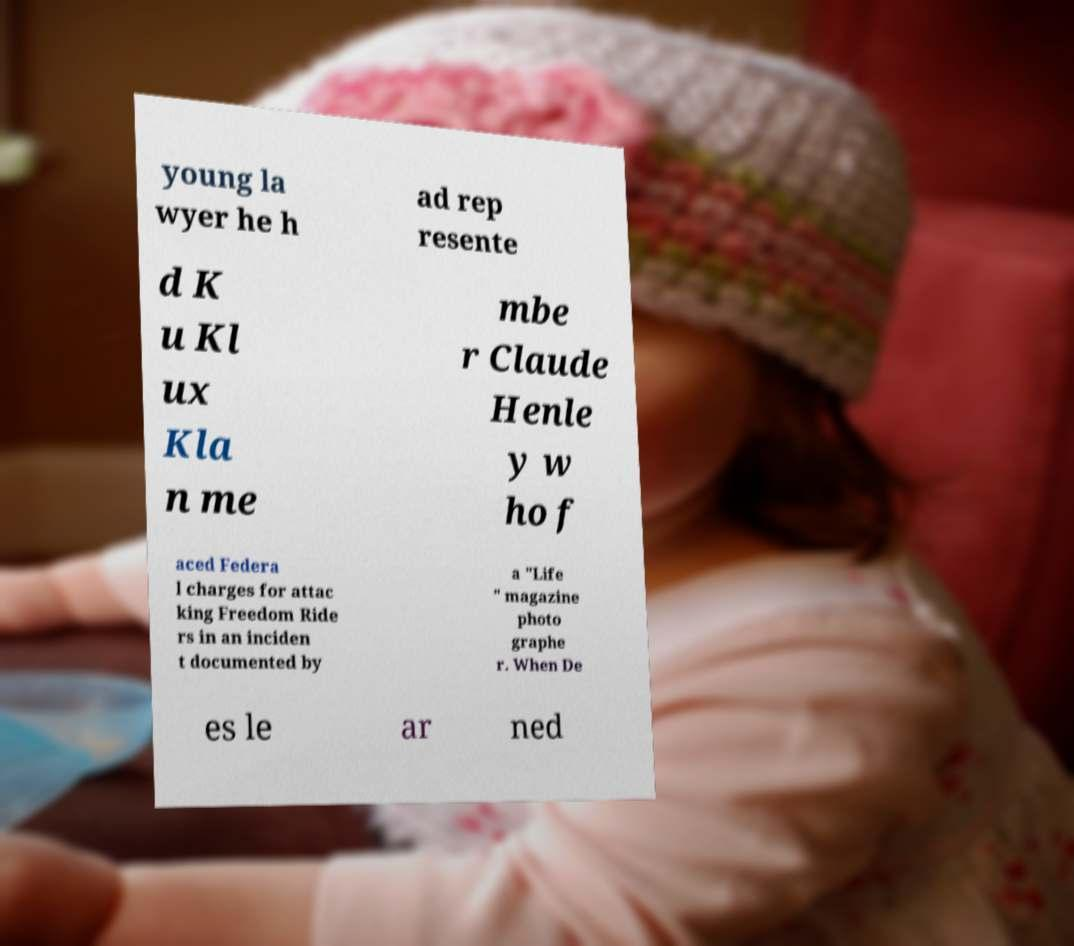Please read and relay the text visible in this image. What does it say? young la wyer he h ad rep resente d K u Kl ux Kla n me mbe r Claude Henle y w ho f aced Federa l charges for attac king Freedom Ride rs in an inciden t documented by a "Life " magazine photo graphe r. When De es le ar ned 